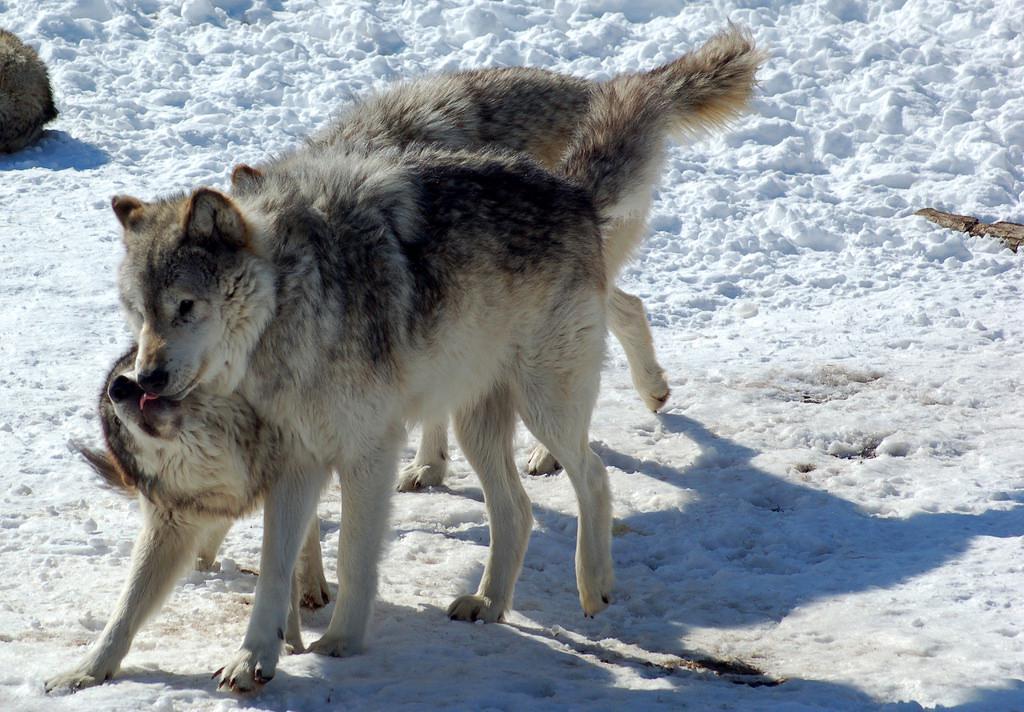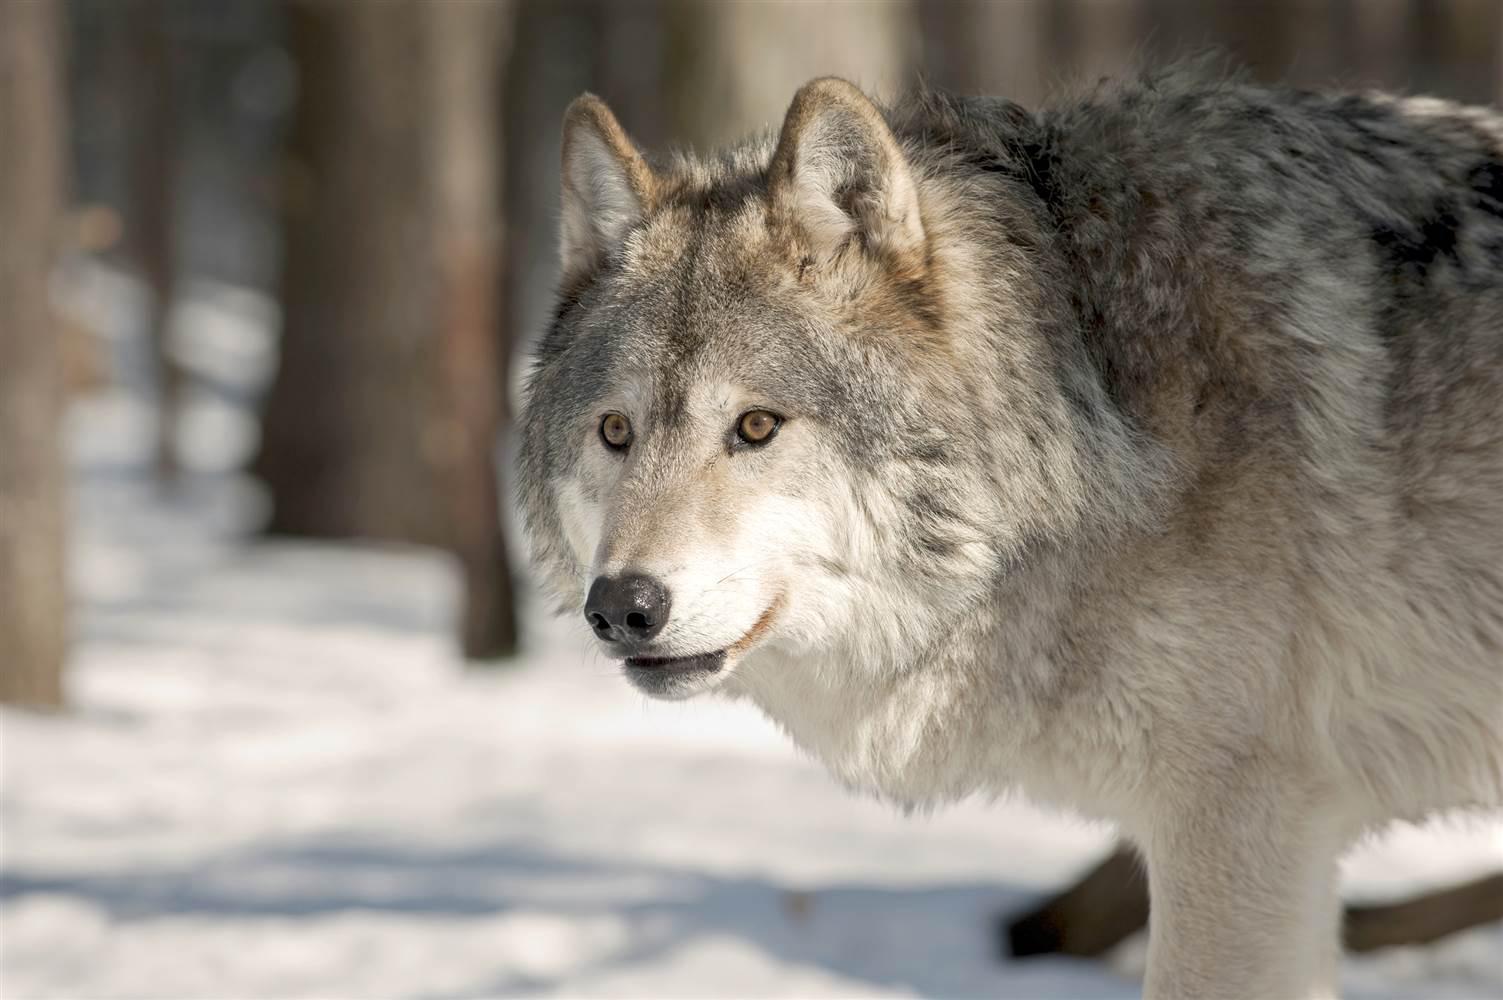The first image is the image on the left, the second image is the image on the right. For the images displayed, is the sentence "The left image contains no more than two wolves." factually correct? Answer yes or no. Yes. The first image is the image on the left, the second image is the image on the right. For the images displayed, is the sentence "An image contains exactly two wolves, which are close together in a snowy scene." factually correct? Answer yes or no. Yes. 